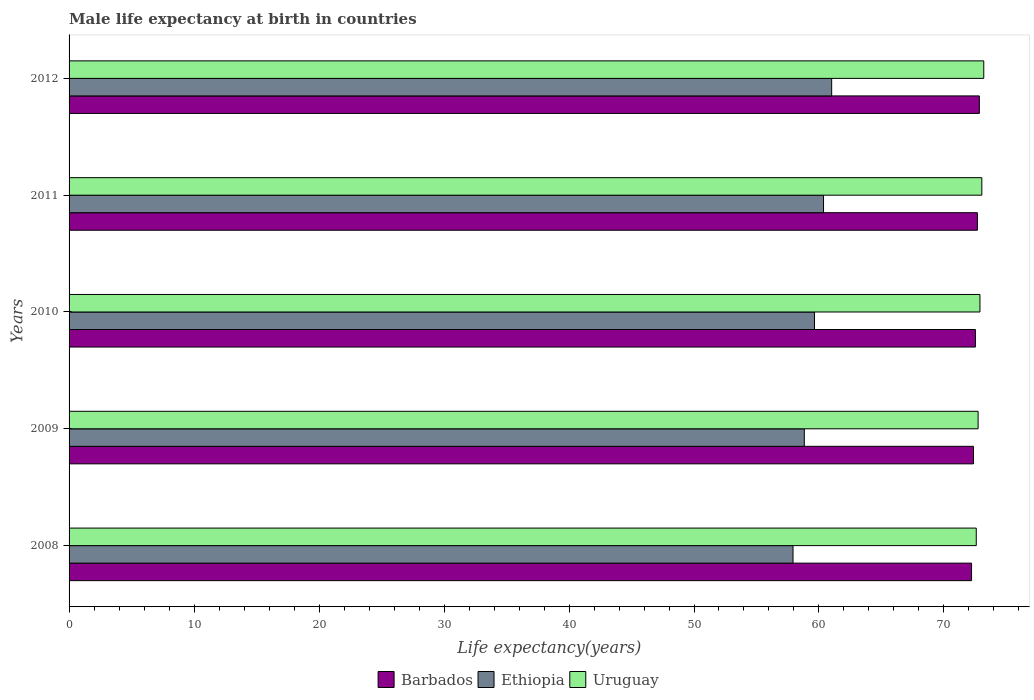How many groups of bars are there?
Keep it short and to the point. 5. Are the number of bars on each tick of the Y-axis equal?
Make the answer very short. Yes. How many bars are there on the 1st tick from the bottom?
Offer a terse response. 3. What is the label of the 4th group of bars from the top?
Your answer should be compact. 2009. In how many cases, is the number of bars for a given year not equal to the number of legend labels?
Provide a short and direct response. 0. What is the male life expectancy at birth in Uruguay in 2012?
Ensure brevity in your answer.  73.18. Across all years, what is the maximum male life expectancy at birth in Barbados?
Keep it short and to the point. 72.83. Across all years, what is the minimum male life expectancy at birth in Ethiopia?
Give a very brief answer. 57.92. What is the total male life expectancy at birth in Ethiopia in the graph?
Ensure brevity in your answer.  297.77. What is the difference between the male life expectancy at birth in Uruguay in 2010 and that in 2011?
Make the answer very short. -0.15. What is the difference between the male life expectancy at birth in Ethiopia in 2010 and the male life expectancy at birth in Uruguay in 2009?
Provide a succinct answer. -13.09. What is the average male life expectancy at birth in Ethiopia per year?
Ensure brevity in your answer.  59.55. In the year 2008, what is the difference between the male life expectancy at birth in Ethiopia and male life expectancy at birth in Barbados?
Provide a succinct answer. -14.28. What is the ratio of the male life expectancy at birth in Barbados in 2008 to that in 2010?
Make the answer very short. 1. Is the difference between the male life expectancy at birth in Ethiopia in 2008 and 2011 greater than the difference between the male life expectancy at birth in Barbados in 2008 and 2011?
Offer a terse response. No. What is the difference between the highest and the second highest male life expectancy at birth in Ethiopia?
Keep it short and to the point. 0.65. Is the sum of the male life expectancy at birth in Barbados in 2011 and 2012 greater than the maximum male life expectancy at birth in Ethiopia across all years?
Keep it short and to the point. Yes. What does the 1st bar from the top in 2011 represents?
Your answer should be compact. Uruguay. What does the 3rd bar from the bottom in 2010 represents?
Offer a very short reply. Uruguay. Is it the case that in every year, the sum of the male life expectancy at birth in Ethiopia and male life expectancy at birth in Barbados is greater than the male life expectancy at birth in Uruguay?
Your answer should be compact. Yes. Are the values on the major ticks of X-axis written in scientific E-notation?
Your response must be concise. No. Does the graph contain grids?
Your response must be concise. No. Where does the legend appear in the graph?
Provide a short and direct response. Bottom center. How many legend labels are there?
Provide a succinct answer. 3. How are the legend labels stacked?
Provide a short and direct response. Horizontal. What is the title of the graph?
Your response must be concise. Male life expectancy at birth in countries. What is the label or title of the X-axis?
Your answer should be compact. Life expectancy(years). What is the label or title of the Y-axis?
Keep it short and to the point. Years. What is the Life expectancy(years) in Barbados in 2008?
Ensure brevity in your answer.  72.21. What is the Life expectancy(years) in Ethiopia in 2008?
Offer a terse response. 57.92. What is the Life expectancy(years) of Uruguay in 2008?
Offer a terse response. 72.58. What is the Life expectancy(years) of Barbados in 2009?
Keep it short and to the point. 72.36. What is the Life expectancy(years) of Ethiopia in 2009?
Your answer should be compact. 58.83. What is the Life expectancy(years) in Uruguay in 2009?
Your response must be concise. 72.73. What is the Life expectancy(years) in Barbados in 2010?
Give a very brief answer. 72.52. What is the Life expectancy(years) of Ethiopia in 2010?
Your response must be concise. 59.64. What is the Life expectancy(years) in Uruguay in 2010?
Keep it short and to the point. 72.88. What is the Life expectancy(years) in Barbados in 2011?
Offer a terse response. 72.67. What is the Life expectancy(years) of Ethiopia in 2011?
Give a very brief answer. 60.36. What is the Life expectancy(years) of Uruguay in 2011?
Your answer should be very brief. 73.03. What is the Life expectancy(years) of Barbados in 2012?
Your answer should be compact. 72.83. What is the Life expectancy(years) in Ethiopia in 2012?
Provide a succinct answer. 61.02. What is the Life expectancy(years) in Uruguay in 2012?
Provide a short and direct response. 73.18. Across all years, what is the maximum Life expectancy(years) in Barbados?
Provide a short and direct response. 72.83. Across all years, what is the maximum Life expectancy(years) in Ethiopia?
Offer a very short reply. 61.02. Across all years, what is the maximum Life expectancy(years) of Uruguay?
Give a very brief answer. 73.18. Across all years, what is the minimum Life expectancy(years) in Barbados?
Your response must be concise. 72.21. Across all years, what is the minimum Life expectancy(years) in Ethiopia?
Your response must be concise. 57.92. Across all years, what is the minimum Life expectancy(years) in Uruguay?
Your answer should be very brief. 72.58. What is the total Life expectancy(years) of Barbados in the graph?
Give a very brief answer. 362.59. What is the total Life expectancy(years) in Ethiopia in the graph?
Offer a terse response. 297.77. What is the total Life expectancy(years) in Uruguay in the graph?
Keep it short and to the point. 364.41. What is the difference between the Life expectancy(years) of Barbados in 2008 and that in 2009?
Keep it short and to the point. -0.15. What is the difference between the Life expectancy(years) of Ethiopia in 2008 and that in 2009?
Give a very brief answer. -0.9. What is the difference between the Life expectancy(years) of Uruguay in 2008 and that in 2009?
Provide a short and direct response. -0.15. What is the difference between the Life expectancy(years) of Barbados in 2008 and that in 2010?
Your response must be concise. -0.31. What is the difference between the Life expectancy(years) of Ethiopia in 2008 and that in 2010?
Ensure brevity in your answer.  -1.72. What is the difference between the Life expectancy(years) of Uruguay in 2008 and that in 2010?
Your response must be concise. -0.29. What is the difference between the Life expectancy(years) of Barbados in 2008 and that in 2011?
Your response must be concise. -0.47. What is the difference between the Life expectancy(years) of Ethiopia in 2008 and that in 2011?
Your response must be concise. -2.44. What is the difference between the Life expectancy(years) in Uruguay in 2008 and that in 2011?
Your answer should be very brief. -0.45. What is the difference between the Life expectancy(years) in Barbados in 2008 and that in 2012?
Ensure brevity in your answer.  -0.62. What is the difference between the Life expectancy(years) in Ethiopia in 2008 and that in 2012?
Your answer should be very brief. -3.09. What is the difference between the Life expectancy(years) in Barbados in 2009 and that in 2010?
Provide a short and direct response. -0.15. What is the difference between the Life expectancy(years) of Ethiopia in 2009 and that in 2010?
Keep it short and to the point. -0.81. What is the difference between the Life expectancy(years) in Uruguay in 2009 and that in 2010?
Offer a terse response. -0.15. What is the difference between the Life expectancy(years) of Barbados in 2009 and that in 2011?
Give a very brief answer. -0.31. What is the difference between the Life expectancy(years) of Ethiopia in 2009 and that in 2011?
Offer a very short reply. -1.54. What is the difference between the Life expectancy(years) of Uruguay in 2009 and that in 2011?
Keep it short and to the point. -0.3. What is the difference between the Life expectancy(years) in Barbados in 2009 and that in 2012?
Your response must be concise. -0.47. What is the difference between the Life expectancy(years) in Ethiopia in 2009 and that in 2012?
Offer a very short reply. -2.19. What is the difference between the Life expectancy(years) in Uruguay in 2009 and that in 2012?
Your answer should be compact. -0.45. What is the difference between the Life expectancy(years) of Barbados in 2010 and that in 2011?
Make the answer very short. -0.16. What is the difference between the Life expectancy(years) in Ethiopia in 2010 and that in 2011?
Your response must be concise. -0.72. What is the difference between the Life expectancy(years) of Uruguay in 2010 and that in 2011?
Offer a very short reply. -0.15. What is the difference between the Life expectancy(years) in Barbados in 2010 and that in 2012?
Your answer should be compact. -0.32. What is the difference between the Life expectancy(years) in Ethiopia in 2010 and that in 2012?
Offer a very short reply. -1.37. What is the difference between the Life expectancy(years) of Uruguay in 2010 and that in 2012?
Give a very brief answer. -0.3. What is the difference between the Life expectancy(years) of Barbados in 2011 and that in 2012?
Offer a very short reply. -0.16. What is the difference between the Life expectancy(years) in Ethiopia in 2011 and that in 2012?
Your response must be concise. -0.65. What is the difference between the Life expectancy(years) of Uruguay in 2011 and that in 2012?
Give a very brief answer. -0.15. What is the difference between the Life expectancy(years) in Barbados in 2008 and the Life expectancy(years) in Ethiopia in 2009?
Provide a short and direct response. 13.38. What is the difference between the Life expectancy(years) of Barbados in 2008 and the Life expectancy(years) of Uruguay in 2009?
Make the answer very short. -0.53. What is the difference between the Life expectancy(years) of Ethiopia in 2008 and the Life expectancy(years) of Uruguay in 2009?
Ensure brevity in your answer.  -14.81. What is the difference between the Life expectancy(years) of Barbados in 2008 and the Life expectancy(years) of Ethiopia in 2010?
Keep it short and to the point. 12.57. What is the difference between the Life expectancy(years) of Barbados in 2008 and the Life expectancy(years) of Uruguay in 2010?
Offer a terse response. -0.67. What is the difference between the Life expectancy(years) of Ethiopia in 2008 and the Life expectancy(years) of Uruguay in 2010?
Provide a short and direct response. -14.96. What is the difference between the Life expectancy(years) in Barbados in 2008 and the Life expectancy(years) in Ethiopia in 2011?
Your answer should be very brief. 11.84. What is the difference between the Life expectancy(years) of Barbados in 2008 and the Life expectancy(years) of Uruguay in 2011?
Your answer should be compact. -0.82. What is the difference between the Life expectancy(years) in Ethiopia in 2008 and the Life expectancy(years) in Uruguay in 2011?
Provide a short and direct response. -15.11. What is the difference between the Life expectancy(years) in Barbados in 2008 and the Life expectancy(years) in Ethiopia in 2012?
Your answer should be compact. 11.19. What is the difference between the Life expectancy(years) of Barbados in 2008 and the Life expectancy(years) of Uruguay in 2012?
Your answer should be compact. -0.98. What is the difference between the Life expectancy(years) in Ethiopia in 2008 and the Life expectancy(years) in Uruguay in 2012?
Provide a short and direct response. -15.26. What is the difference between the Life expectancy(years) of Barbados in 2009 and the Life expectancy(years) of Ethiopia in 2010?
Offer a terse response. 12.72. What is the difference between the Life expectancy(years) of Barbados in 2009 and the Life expectancy(years) of Uruguay in 2010?
Ensure brevity in your answer.  -0.52. What is the difference between the Life expectancy(years) in Ethiopia in 2009 and the Life expectancy(years) in Uruguay in 2010?
Make the answer very short. -14.05. What is the difference between the Life expectancy(years) in Barbados in 2009 and the Life expectancy(years) in Ethiopia in 2011?
Offer a terse response. 12. What is the difference between the Life expectancy(years) in Barbados in 2009 and the Life expectancy(years) in Uruguay in 2011?
Give a very brief answer. -0.67. What is the difference between the Life expectancy(years) in Ethiopia in 2009 and the Life expectancy(years) in Uruguay in 2011?
Give a very brief answer. -14.2. What is the difference between the Life expectancy(years) in Barbados in 2009 and the Life expectancy(years) in Ethiopia in 2012?
Your response must be concise. 11.35. What is the difference between the Life expectancy(years) in Barbados in 2009 and the Life expectancy(years) in Uruguay in 2012?
Provide a succinct answer. -0.82. What is the difference between the Life expectancy(years) in Ethiopia in 2009 and the Life expectancy(years) in Uruguay in 2012?
Your answer should be compact. -14.36. What is the difference between the Life expectancy(years) in Barbados in 2010 and the Life expectancy(years) in Ethiopia in 2011?
Offer a terse response. 12.15. What is the difference between the Life expectancy(years) in Barbados in 2010 and the Life expectancy(years) in Uruguay in 2011?
Your answer should be very brief. -0.51. What is the difference between the Life expectancy(years) in Ethiopia in 2010 and the Life expectancy(years) in Uruguay in 2011?
Offer a very short reply. -13.39. What is the difference between the Life expectancy(years) of Barbados in 2010 and the Life expectancy(years) of Ethiopia in 2012?
Offer a very short reply. 11.5. What is the difference between the Life expectancy(years) in Barbados in 2010 and the Life expectancy(years) in Uruguay in 2012?
Your answer should be compact. -0.67. What is the difference between the Life expectancy(years) of Ethiopia in 2010 and the Life expectancy(years) of Uruguay in 2012?
Make the answer very short. -13.54. What is the difference between the Life expectancy(years) in Barbados in 2011 and the Life expectancy(years) in Ethiopia in 2012?
Provide a short and direct response. 11.66. What is the difference between the Life expectancy(years) in Barbados in 2011 and the Life expectancy(years) in Uruguay in 2012?
Offer a terse response. -0.51. What is the difference between the Life expectancy(years) in Ethiopia in 2011 and the Life expectancy(years) in Uruguay in 2012?
Offer a terse response. -12.82. What is the average Life expectancy(years) in Barbados per year?
Keep it short and to the point. 72.52. What is the average Life expectancy(years) of Ethiopia per year?
Provide a succinct answer. 59.55. What is the average Life expectancy(years) of Uruguay per year?
Your answer should be compact. 72.88. In the year 2008, what is the difference between the Life expectancy(years) in Barbados and Life expectancy(years) in Ethiopia?
Make the answer very short. 14.28. In the year 2008, what is the difference between the Life expectancy(years) of Barbados and Life expectancy(years) of Uruguay?
Provide a succinct answer. -0.38. In the year 2008, what is the difference between the Life expectancy(years) of Ethiopia and Life expectancy(years) of Uruguay?
Provide a succinct answer. -14.66. In the year 2009, what is the difference between the Life expectancy(years) in Barbados and Life expectancy(years) in Ethiopia?
Your response must be concise. 13.54. In the year 2009, what is the difference between the Life expectancy(years) of Barbados and Life expectancy(years) of Uruguay?
Provide a succinct answer. -0.37. In the year 2009, what is the difference between the Life expectancy(years) in Ethiopia and Life expectancy(years) in Uruguay?
Make the answer very short. -13.9. In the year 2010, what is the difference between the Life expectancy(years) in Barbados and Life expectancy(years) in Ethiopia?
Provide a succinct answer. 12.88. In the year 2010, what is the difference between the Life expectancy(years) of Barbados and Life expectancy(years) of Uruguay?
Your response must be concise. -0.36. In the year 2010, what is the difference between the Life expectancy(years) in Ethiopia and Life expectancy(years) in Uruguay?
Offer a terse response. -13.24. In the year 2011, what is the difference between the Life expectancy(years) in Barbados and Life expectancy(years) in Ethiopia?
Give a very brief answer. 12.31. In the year 2011, what is the difference between the Life expectancy(years) of Barbados and Life expectancy(years) of Uruguay?
Your answer should be very brief. -0.35. In the year 2011, what is the difference between the Life expectancy(years) of Ethiopia and Life expectancy(years) of Uruguay?
Your response must be concise. -12.66. In the year 2012, what is the difference between the Life expectancy(years) in Barbados and Life expectancy(years) in Ethiopia?
Provide a short and direct response. 11.82. In the year 2012, what is the difference between the Life expectancy(years) in Barbados and Life expectancy(years) in Uruguay?
Your response must be concise. -0.35. In the year 2012, what is the difference between the Life expectancy(years) of Ethiopia and Life expectancy(years) of Uruguay?
Your response must be concise. -12.17. What is the ratio of the Life expectancy(years) of Ethiopia in 2008 to that in 2009?
Offer a very short reply. 0.98. What is the ratio of the Life expectancy(years) of Ethiopia in 2008 to that in 2010?
Your response must be concise. 0.97. What is the ratio of the Life expectancy(years) in Ethiopia in 2008 to that in 2011?
Offer a terse response. 0.96. What is the ratio of the Life expectancy(years) of Uruguay in 2008 to that in 2011?
Keep it short and to the point. 0.99. What is the ratio of the Life expectancy(years) in Ethiopia in 2008 to that in 2012?
Ensure brevity in your answer.  0.95. What is the ratio of the Life expectancy(years) in Uruguay in 2008 to that in 2012?
Provide a short and direct response. 0.99. What is the ratio of the Life expectancy(years) of Ethiopia in 2009 to that in 2010?
Offer a very short reply. 0.99. What is the ratio of the Life expectancy(years) of Barbados in 2009 to that in 2011?
Ensure brevity in your answer.  1. What is the ratio of the Life expectancy(years) of Ethiopia in 2009 to that in 2011?
Your answer should be very brief. 0.97. What is the ratio of the Life expectancy(years) of Ethiopia in 2009 to that in 2012?
Provide a short and direct response. 0.96. What is the ratio of the Life expectancy(years) in Uruguay in 2009 to that in 2012?
Ensure brevity in your answer.  0.99. What is the ratio of the Life expectancy(years) of Ethiopia in 2010 to that in 2011?
Your response must be concise. 0.99. What is the ratio of the Life expectancy(years) in Ethiopia in 2010 to that in 2012?
Provide a succinct answer. 0.98. What is the ratio of the Life expectancy(years) of Ethiopia in 2011 to that in 2012?
Give a very brief answer. 0.99. What is the difference between the highest and the second highest Life expectancy(years) in Barbados?
Ensure brevity in your answer.  0.16. What is the difference between the highest and the second highest Life expectancy(years) of Ethiopia?
Offer a very short reply. 0.65. What is the difference between the highest and the second highest Life expectancy(years) of Uruguay?
Offer a terse response. 0.15. What is the difference between the highest and the lowest Life expectancy(years) of Barbados?
Your answer should be compact. 0.62. What is the difference between the highest and the lowest Life expectancy(years) of Ethiopia?
Ensure brevity in your answer.  3.09. 